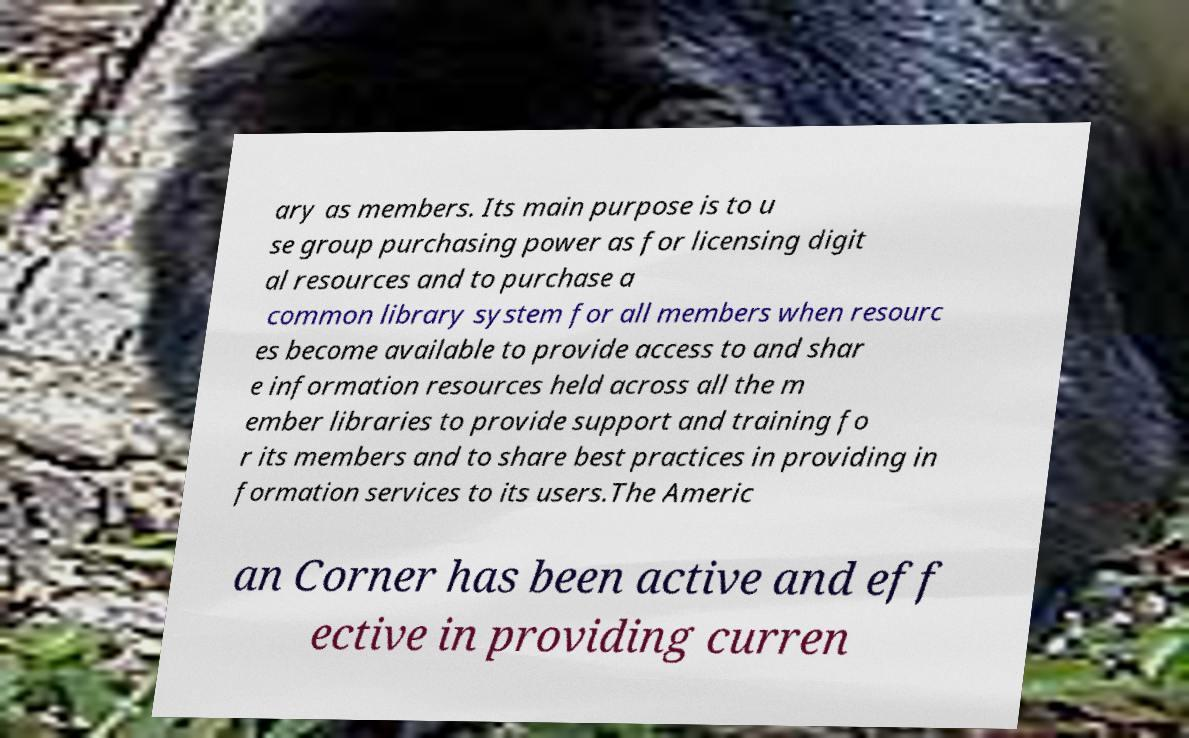There's text embedded in this image that I need extracted. Can you transcribe it verbatim? ary as members. Its main purpose is to u se group purchasing power as for licensing digit al resources and to purchase a common library system for all members when resourc es become available to provide access to and shar e information resources held across all the m ember libraries to provide support and training fo r its members and to share best practices in providing in formation services to its users.The Americ an Corner has been active and eff ective in providing curren 